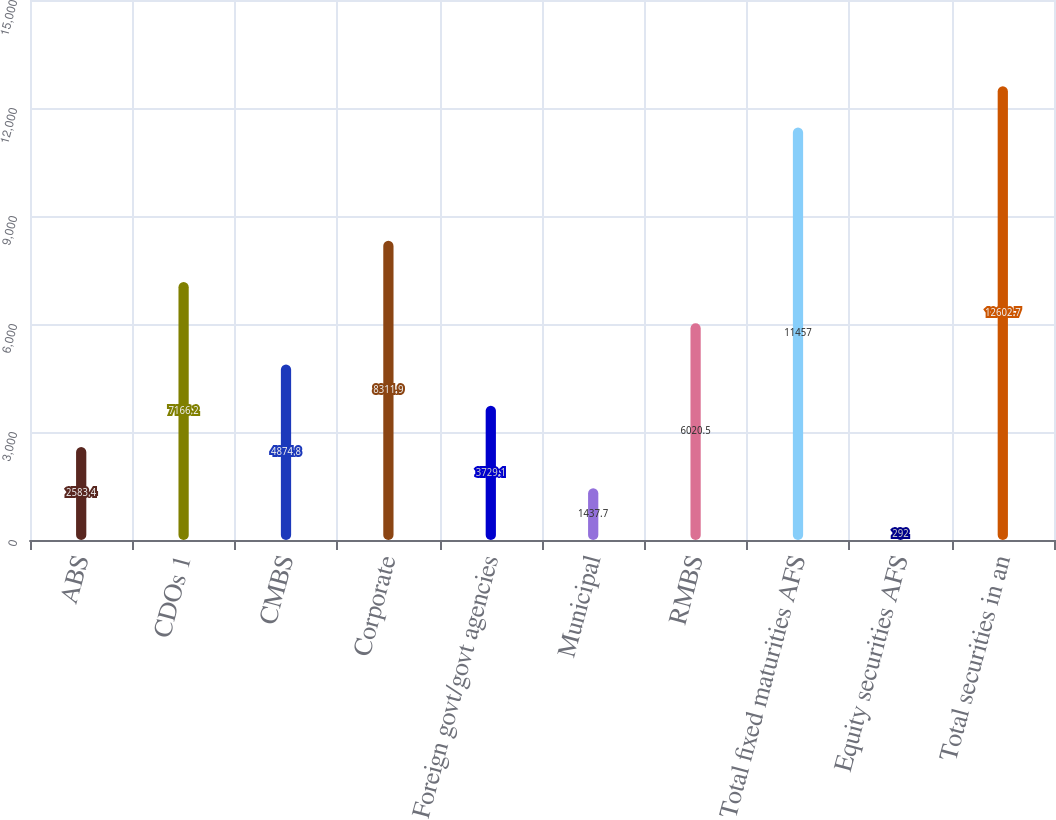<chart> <loc_0><loc_0><loc_500><loc_500><bar_chart><fcel>ABS<fcel>CDOs 1<fcel>CMBS<fcel>Corporate<fcel>Foreign govt/govt agencies<fcel>Municipal<fcel>RMBS<fcel>Total fixed maturities AFS<fcel>Equity securities AFS<fcel>Total securities in an<nl><fcel>2583.4<fcel>7166.2<fcel>4874.8<fcel>8311.9<fcel>3729.1<fcel>1437.7<fcel>6020.5<fcel>11457<fcel>292<fcel>12602.7<nl></chart> 